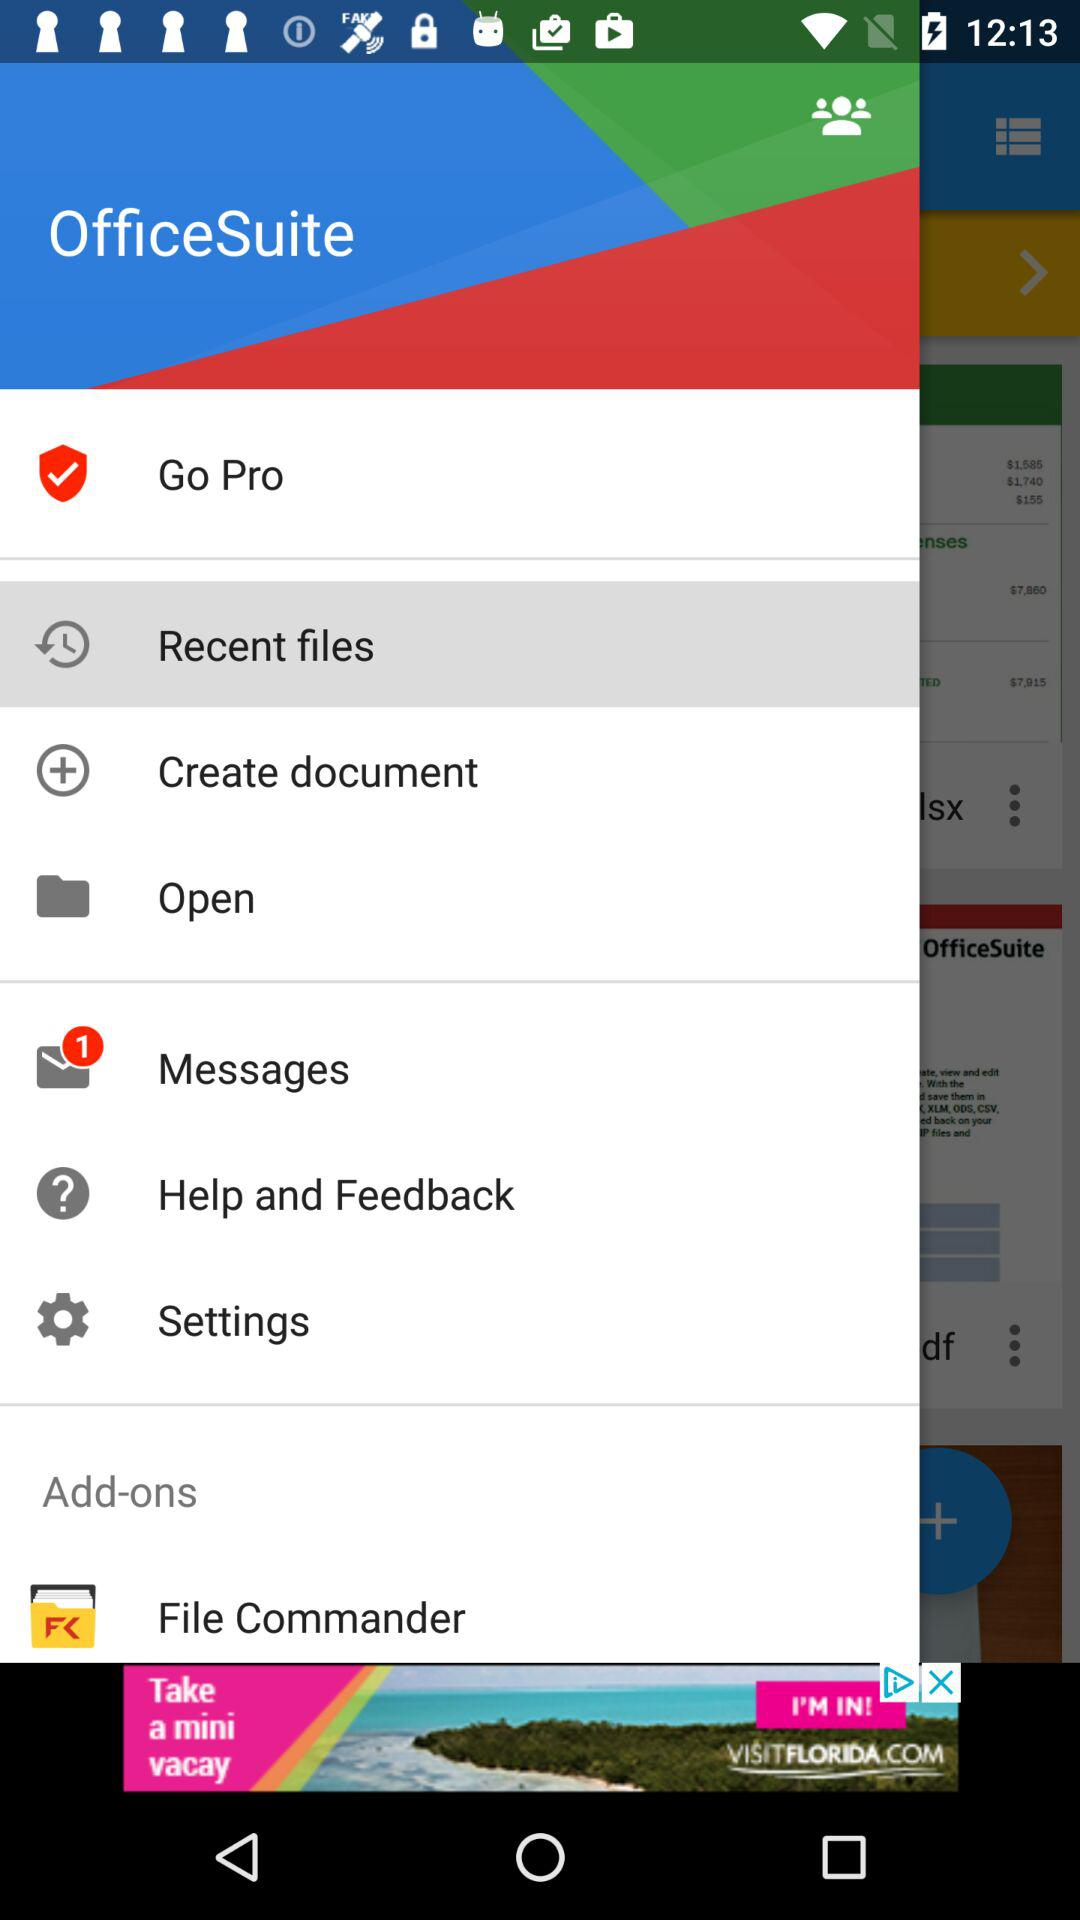How many unread messages are there? There is 1 unread message. 